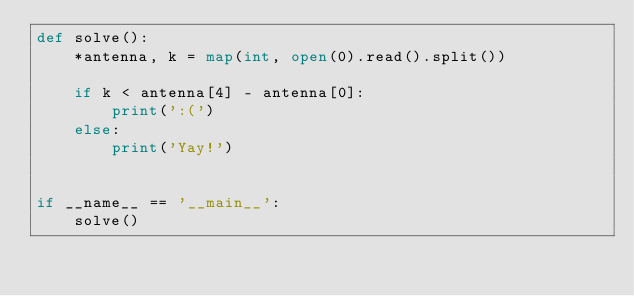<code> <loc_0><loc_0><loc_500><loc_500><_Python_>def solve():
    *antenna, k = map(int, open(0).read().split())
    
    if k < antenna[4] - antenna[0]:
        print(':(')
    else:
        print('Yay!')


if __name__ == '__main__':
    solve()</code> 